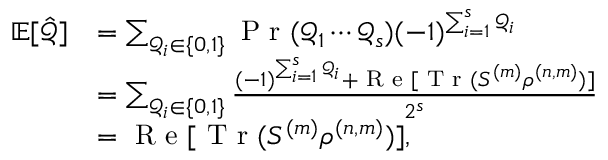<formula> <loc_0><loc_0><loc_500><loc_500>\begin{array} { r l } { \mathbb { E } [ \hat { \mathcal { Q } } ] } & { = \sum _ { \mathcal { Q } _ { i } \in \{ 0 , 1 \} } P r ( \mathcal { Q } _ { 1 } \cdots \mathcal { Q } _ { s } ) ( - 1 ) ^ { \sum _ { i = 1 } ^ { s } \mathcal { Q } _ { i } } } \\ & { = \sum _ { \mathcal { Q } _ { i } \in \{ 0 , 1 \} } \frac { ( - 1 ) ^ { \sum _ { i = 1 } ^ { s } \mathcal { Q } _ { i } } + R e [ T r ( S ^ { ( m ) } \rho ^ { ( n , m ) } ) ] } { 2 ^ { s } } } \\ & { = R e [ T r ( S ^ { ( m ) } \rho ^ { ( n , m ) } ) ] , } \end{array}</formula> 